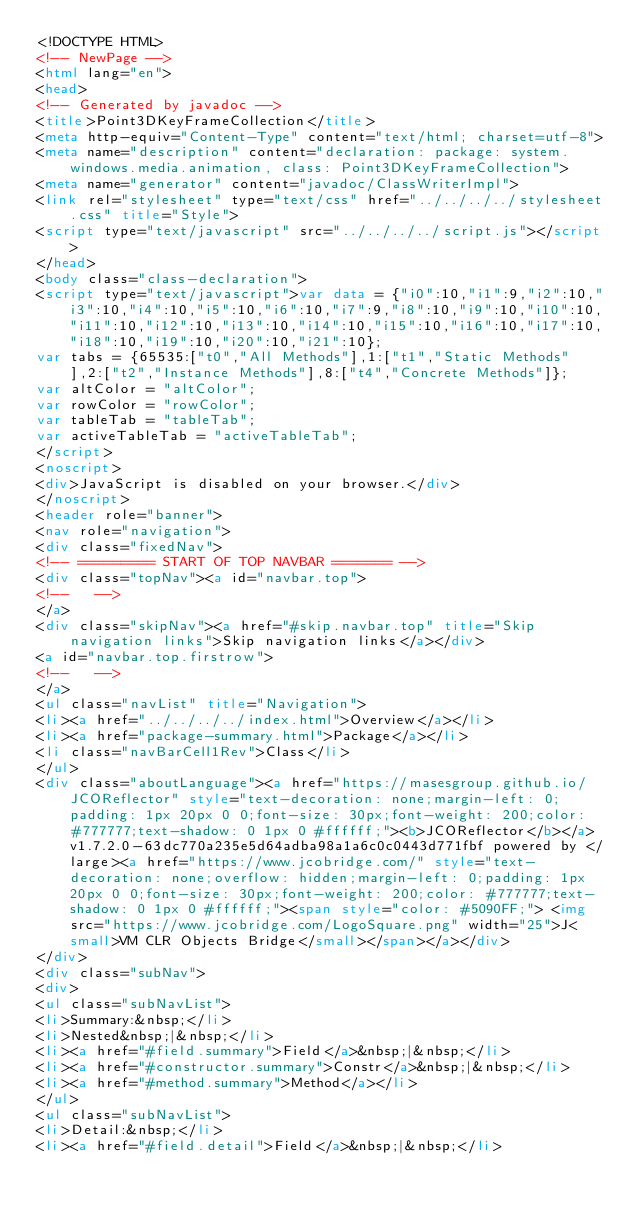<code> <loc_0><loc_0><loc_500><loc_500><_HTML_><!DOCTYPE HTML>
<!-- NewPage -->
<html lang="en">
<head>
<!-- Generated by javadoc -->
<title>Point3DKeyFrameCollection</title>
<meta http-equiv="Content-Type" content="text/html; charset=utf-8">
<meta name="description" content="declaration: package: system.windows.media.animation, class: Point3DKeyFrameCollection">
<meta name="generator" content="javadoc/ClassWriterImpl">
<link rel="stylesheet" type="text/css" href="../../../../stylesheet.css" title="Style">
<script type="text/javascript" src="../../../../script.js"></script>
</head>
<body class="class-declaration">
<script type="text/javascript">var data = {"i0":10,"i1":9,"i2":10,"i3":10,"i4":10,"i5":10,"i6":10,"i7":9,"i8":10,"i9":10,"i10":10,"i11":10,"i12":10,"i13":10,"i14":10,"i15":10,"i16":10,"i17":10,"i18":10,"i19":10,"i20":10,"i21":10};
var tabs = {65535:["t0","All Methods"],1:["t1","Static Methods"],2:["t2","Instance Methods"],8:["t4","Concrete Methods"]};
var altColor = "altColor";
var rowColor = "rowColor";
var tableTab = "tableTab";
var activeTableTab = "activeTableTab";
</script>
<noscript>
<div>JavaScript is disabled on your browser.</div>
</noscript>
<header role="banner">
<nav role="navigation">
<div class="fixedNav">
<!-- ========= START OF TOP NAVBAR ======= -->
<div class="topNav"><a id="navbar.top">
<!--   -->
</a>
<div class="skipNav"><a href="#skip.navbar.top" title="Skip navigation links">Skip navigation links</a></div>
<a id="navbar.top.firstrow">
<!--   -->
</a>
<ul class="navList" title="Navigation">
<li><a href="../../../../index.html">Overview</a></li>
<li><a href="package-summary.html">Package</a></li>
<li class="navBarCell1Rev">Class</li>
</ul>
<div class="aboutLanguage"><a href="https://masesgroup.github.io/JCOReflector" style="text-decoration: none;margin-left: 0;padding: 1px 20px 0 0;font-size: 30px;font-weight: 200;color: #777777;text-shadow: 0 1px 0 #ffffff;"><b>JCOReflector</b></a> v1.7.2.0-63dc770a235e5d64adba98a1a6c0c0443d771fbf powered by </large><a href="https://www.jcobridge.com/" style="text-decoration: none;overflow: hidden;margin-left: 0;padding: 1px 20px 0 0;font-size: 30px;font-weight: 200;color: #777777;text-shadow: 0 1px 0 #ffffff;"><span style="color: #5090FF;"> <img src="https://www.jcobridge.com/LogoSquare.png" width="25">J<small>VM CLR Objects Bridge</small></span></a></div>
</div>
<div class="subNav">
<div>
<ul class="subNavList">
<li>Summary:&nbsp;</li>
<li>Nested&nbsp;|&nbsp;</li>
<li><a href="#field.summary">Field</a>&nbsp;|&nbsp;</li>
<li><a href="#constructor.summary">Constr</a>&nbsp;|&nbsp;</li>
<li><a href="#method.summary">Method</a></li>
</ul>
<ul class="subNavList">
<li>Detail:&nbsp;</li>
<li><a href="#field.detail">Field</a>&nbsp;|&nbsp;</li></code> 